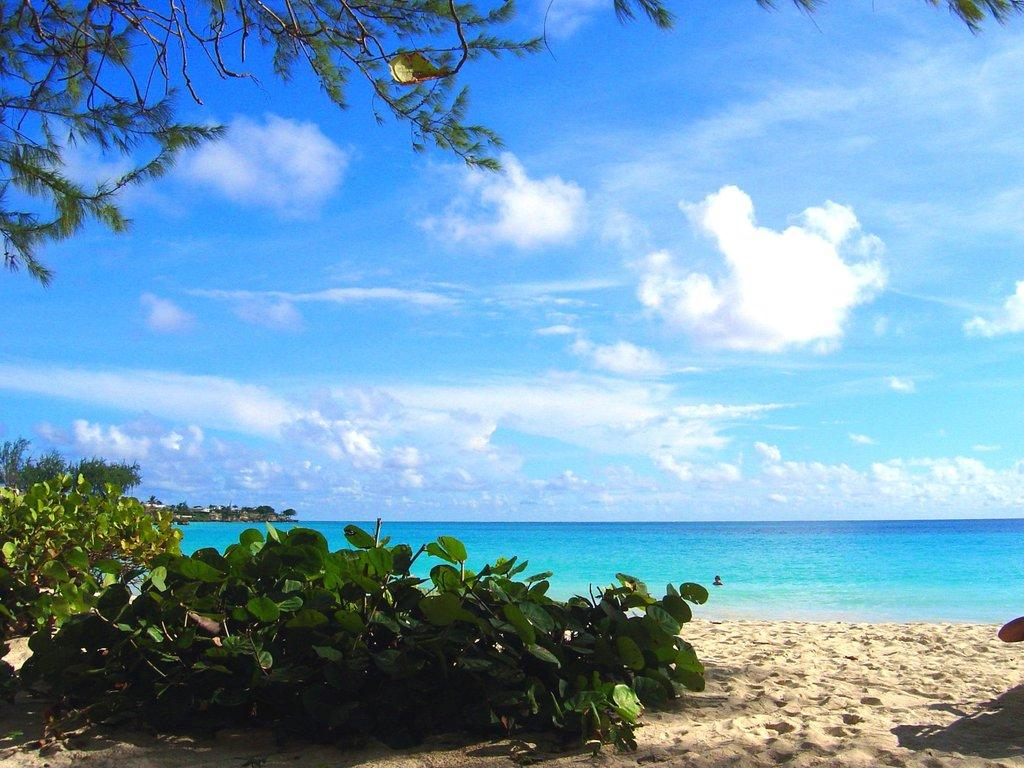What can be seen in the sky in the image? The sky is visible in the image, and clouds are present. What type of vegetation is in the image? Plants are in the image, and branches with leaves are also visible. What is the terrain like in the image? Water and sand are present in the image, suggesting a mix of wet and dry areas. Can you describe any other objects in the image? There are a few other objects in the image, but their specific details are not mentioned in the provided facts. What type of blade is being used by the son in the image? There is no son or blade present in the image. Can you describe the behavior of the ants in the image? There are no ants present in the image. 